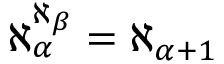Convert formula to latex. <formula><loc_0><loc_0><loc_500><loc_500>\aleph _ { \alpha } ^ { \aleph _ { \beta } } = \aleph _ { \alpha + 1 }</formula> 